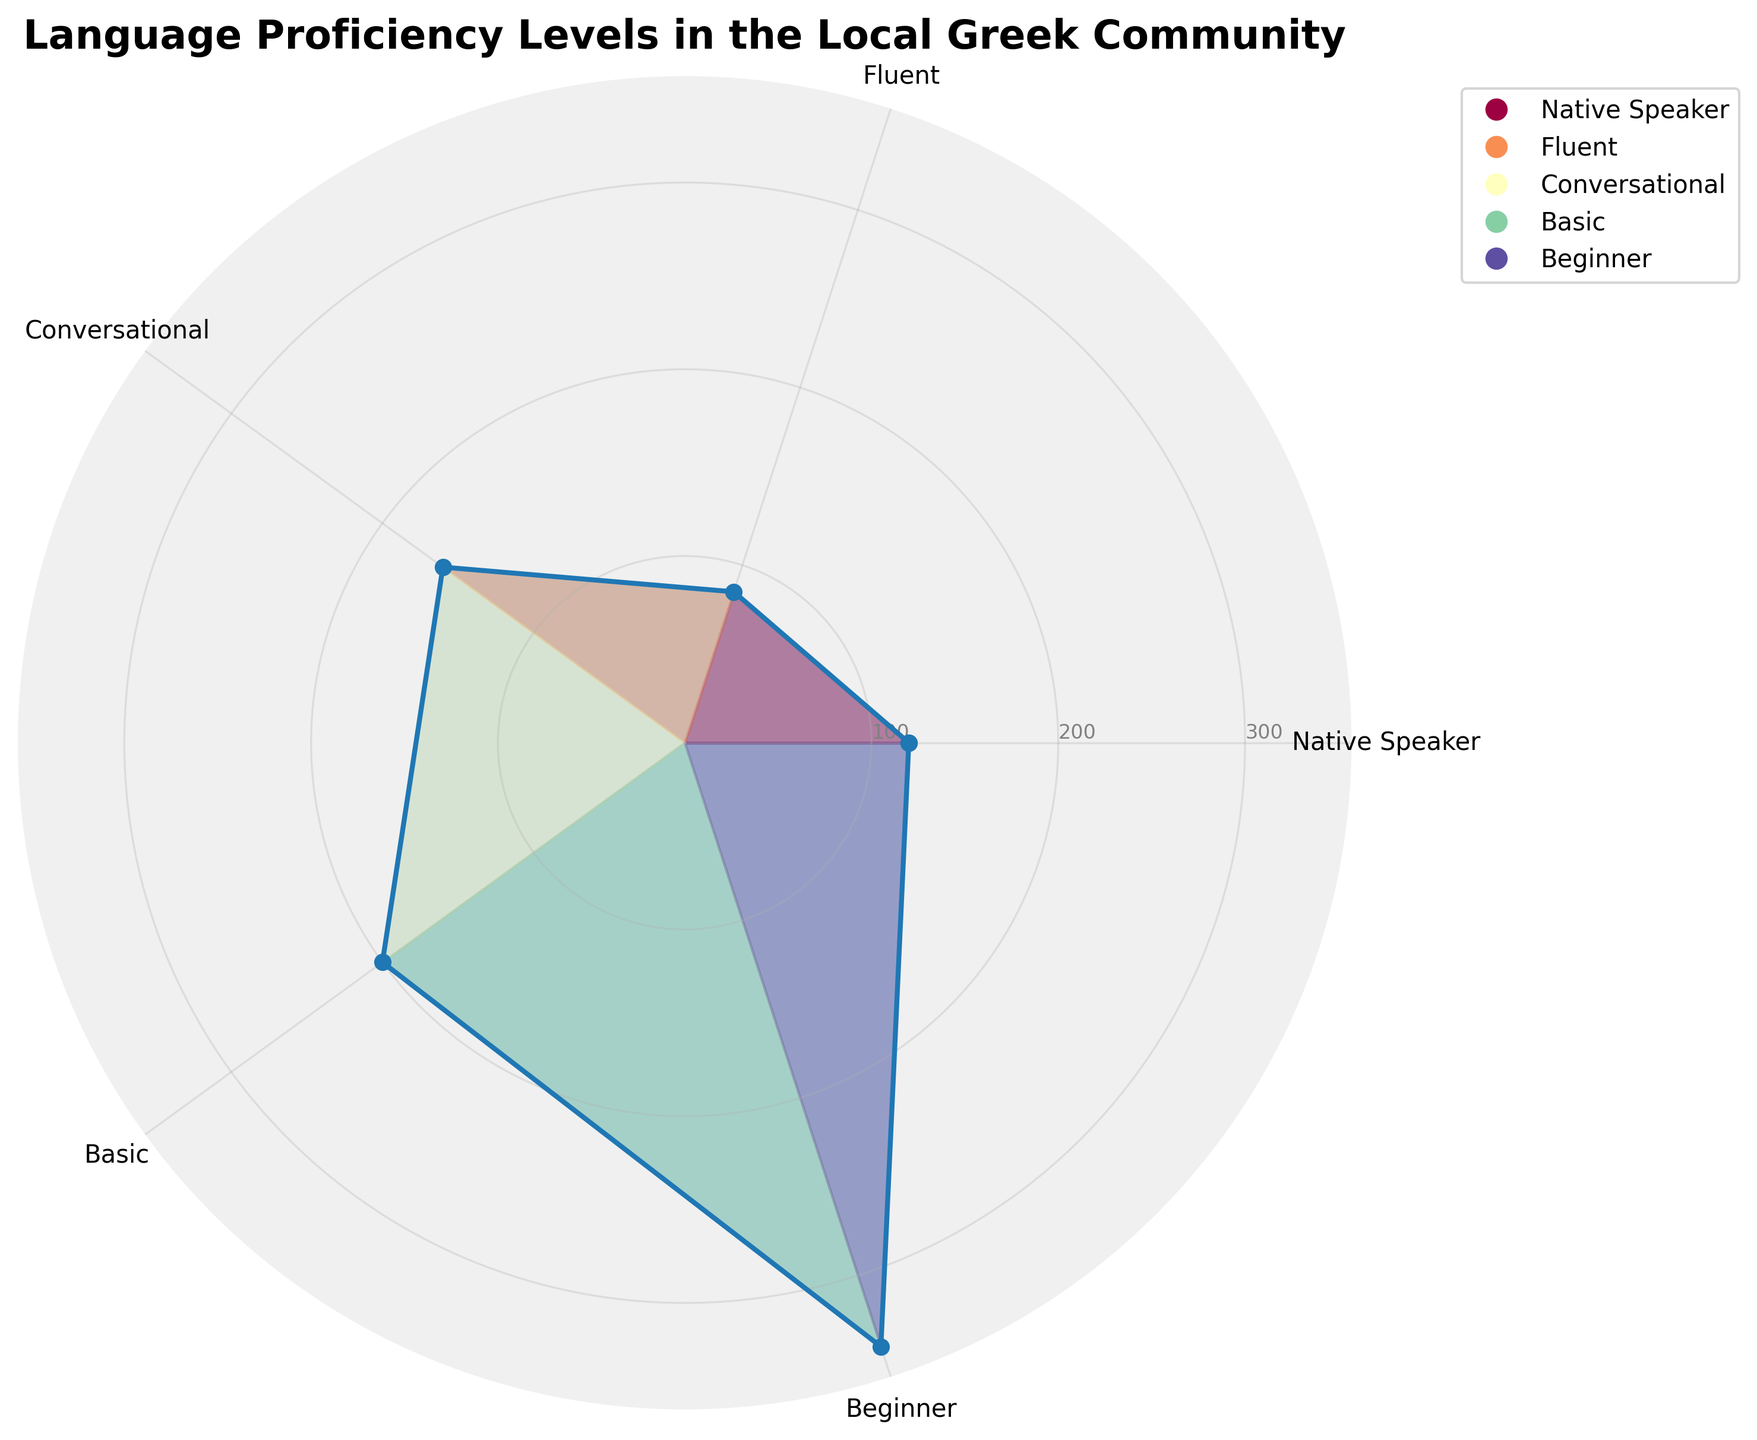What is the title of the polar area chart? The title is located at the top center of the chart and is usually presented in bold and slightly larger font. It provides a summary description of the data being visualized.
Answer: Language Proficiency Levels in the Local Greek Community How many proficiency levels are depicted in the chart? The categories or labels around the circumference of the polar area chart indicate different proficiency levels. Count the labels to get the number of proficiency levels.
Answer: 5 Which proficiency level has the most number of people? Identify the category with the highest radial line or the largest filled area segment on the chart, representing the highest number of people.
Answer: Beginner Which proficiency level has the fewest number of people? Look for the category with the smallest radial line or the smallest filled area segment on the chart, representing the fewest number of people.
Answer: Fluent What is the number of people at the "Conversational" proficiency level? Find the radial line extending from the center that corresponds to the "Conversational" label around the circumference. The length of this line will align with one of the radial ticks to indicate the number.
Answer: 160 What's the total number of people represented in the chart? Sum the values of people for each proficiency level: 120 (Native Speaker) + 85 (Fluent) + 160 (Conversational) + 200 (Basic) + 340 (Beginner).
Answer: 905 By how much does the "Beginner" proficiency level exceed the "Native Speaker" level? Subtract the number of people at the "Native Speaker" proficiency level from the number of people at the "Beginner" proficiency level: 340 - 120.
Answer: 220 Which proficiency levels have more than 150 people? Look for categories with radial lines extending longer than the tick mark at 150. This includes levels whose radial length lies beyond the 150 mark.
Answer: Conversational, Basic, Beginner Is the number of people at the "Basic" proficiency level greater than or less than those at the "Conversational" level? Compare the length of the radial lines for "Basic" and "Conversational" levels. "Basic" should extend further than "Conversational" if it has more people.
Answer: Greater than What is the average number of people across all proficiency levels? Calculate the sum of people in all proficiency levels and divide by the number of levels: (120 + 85 + 160 + 200 + 340) / 5.
Answer: 181 